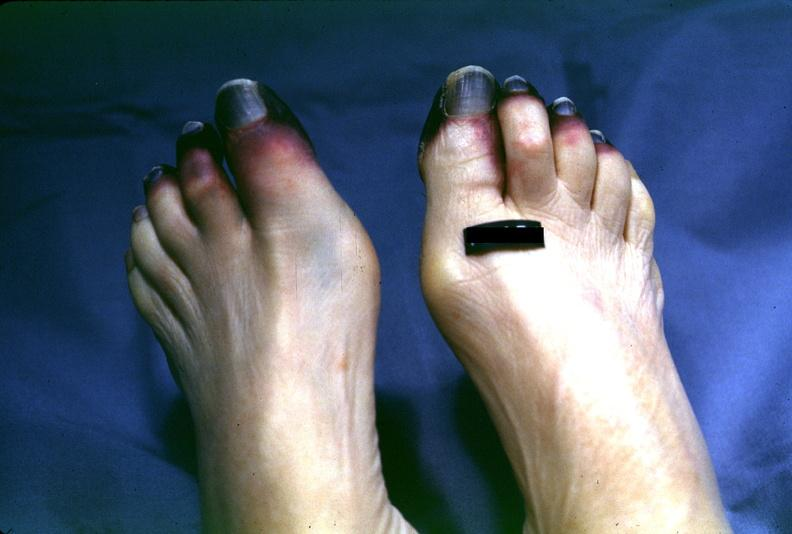does previous slide from this case show toes, dry gangrene?
Answer the question using a single word or phrase. No 